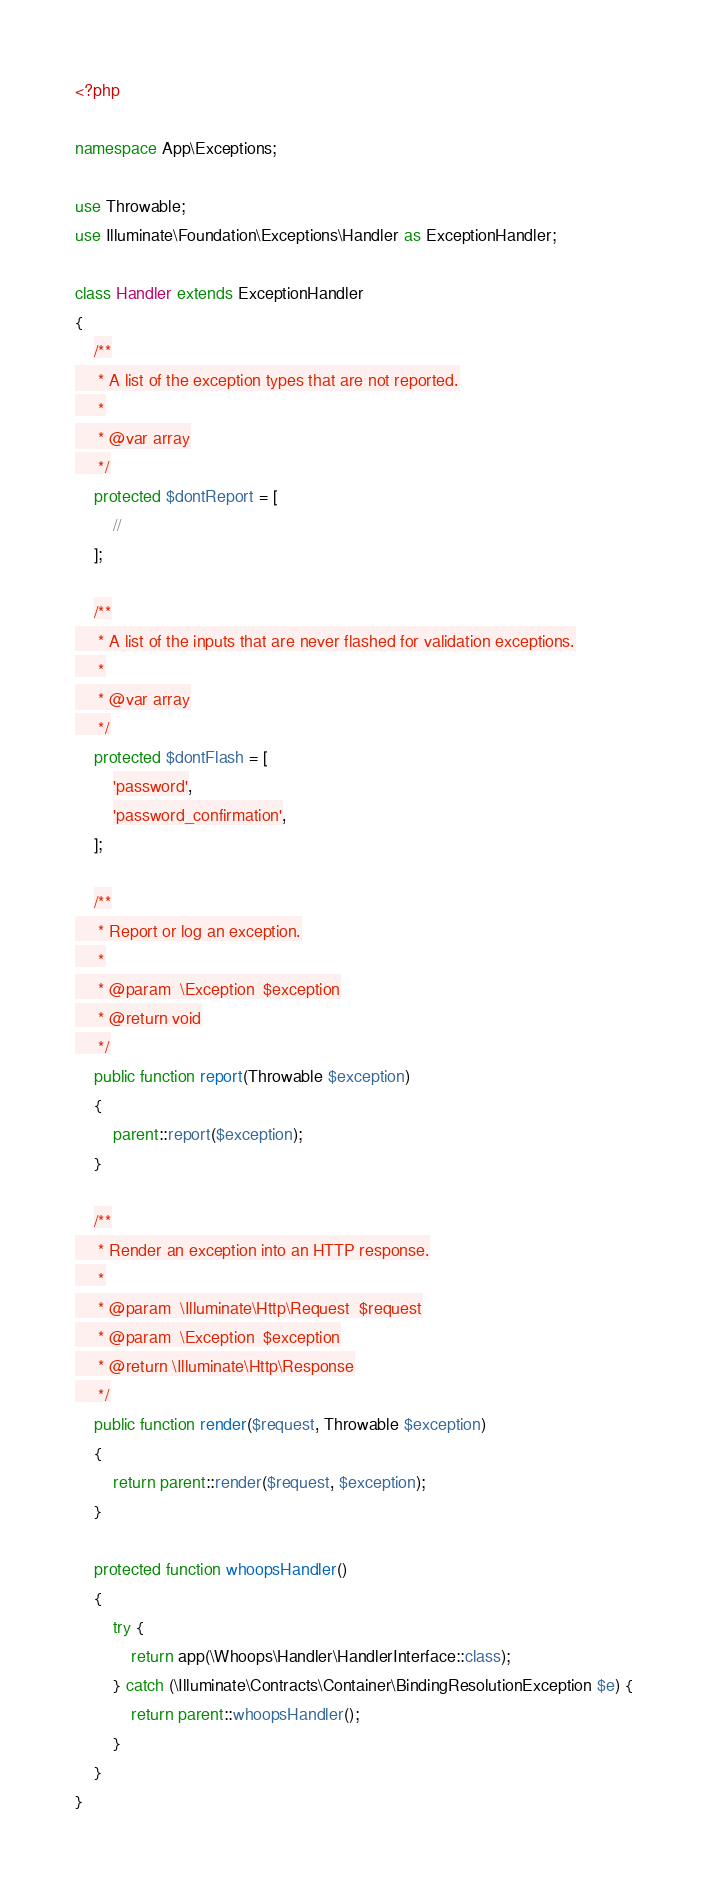Convert code to text. <code><loc_0><loc_0><loc_500><loc_500><_PHP_><?php

namespace App\Exceptions;

use Throwable;
use Illuminate\Foundation\Exceptions\Handler as ExceptionHandler;

class Handler extends ExceptionHandler
{
    /**
     * A list of the exception types that are not reported.
     *
     * @var array
     */
    protected $dontReport = [
        //
    ];

    /**
     * A list of the inputs that are never flashed for validation exceptions.
     *
     * @var array
     */
    protected $dontFlash = [
        'password',
        'password_confirmation',
    ];

    /**
     * Report or log an exception.
     *
     * @param  \Exception  $exception
     * @return void
     */
    public function report(Throwable $exception)
    {
        parent::report($exception);
    }

    /**
     * Render an exception into an HTTP response.
     *
     * @param  \Illuminate\Http\Request  $request
     * @param  \Exception  $exception
     * @return \Illuminate\Http\Response
     */
    public function render($request, Throwable $exception)
    {
        return parent::render($request, $exception);
    }

    protected function whoopsHandler()
    {
        try {
            return app(\Whoops\Handler\HandlerInterface::class);
        } catch (\Illuminate\Contracts\Container\BindingResolutionException $e) {
            return parent::whoopsHandler();
        }
    }
}
</code> 